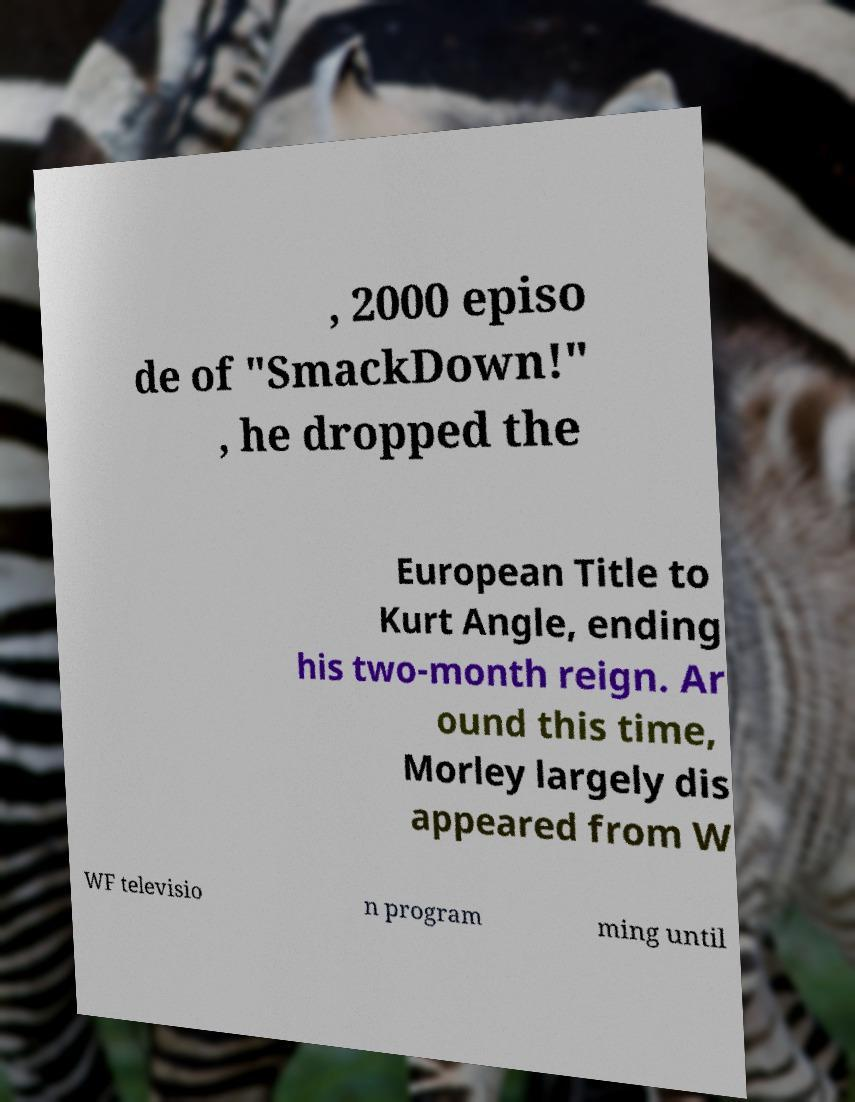Can you read and provide the text displayed in the image?This photo seems to have some interesting text. Can you extract and type it out for me? , 2000 episo de of "SmackDown!" , he dropped the European Title to Kurt Angle, ending his two-month reign. Ar ound this time, Morley largely dis appeared from W WF televisio n program ming until 